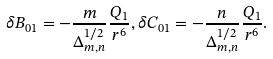<formula> <loc_0><loc_0><loc_500><loc_500>\delta B _ { 0 1 } = - \frac { m } { \Delta _ { m , n } ^ { 1 / 2 } } \frac { Q _ { 1 } } { r ^ { 6 } } , \delta C _ { 0 1 } = - \frac { n } { \Delta _ { m , n } ^ { 1 / 2 } } \frac { Q _ { 1 } } { r ^ { 6 } } .</formula> 